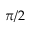Convert formula to latex. <formula><loc_0><loc_0><loc_500><loc_500>\pi / 2</formula> 